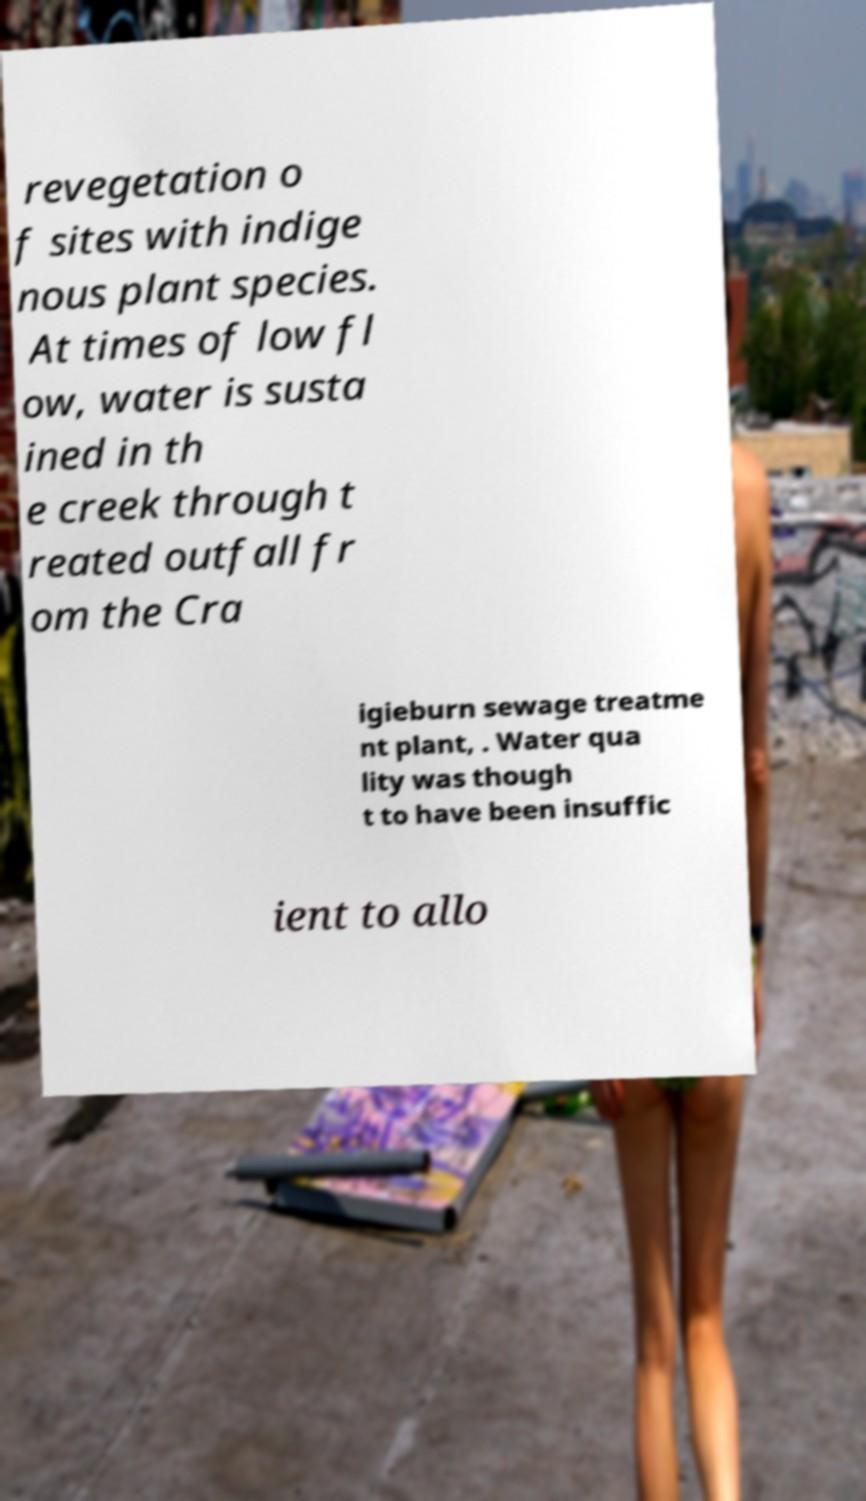I need the written content from this picture converted into text. Can you do that? revegetation o f sites with indige nous plant species. At times of low fl ow, water is susta ined in th e creek through t reated outfall fr om the Cra igieburn sewage treatme nt plant, . Water qua lity was though t to have been insuffic ient to allo 